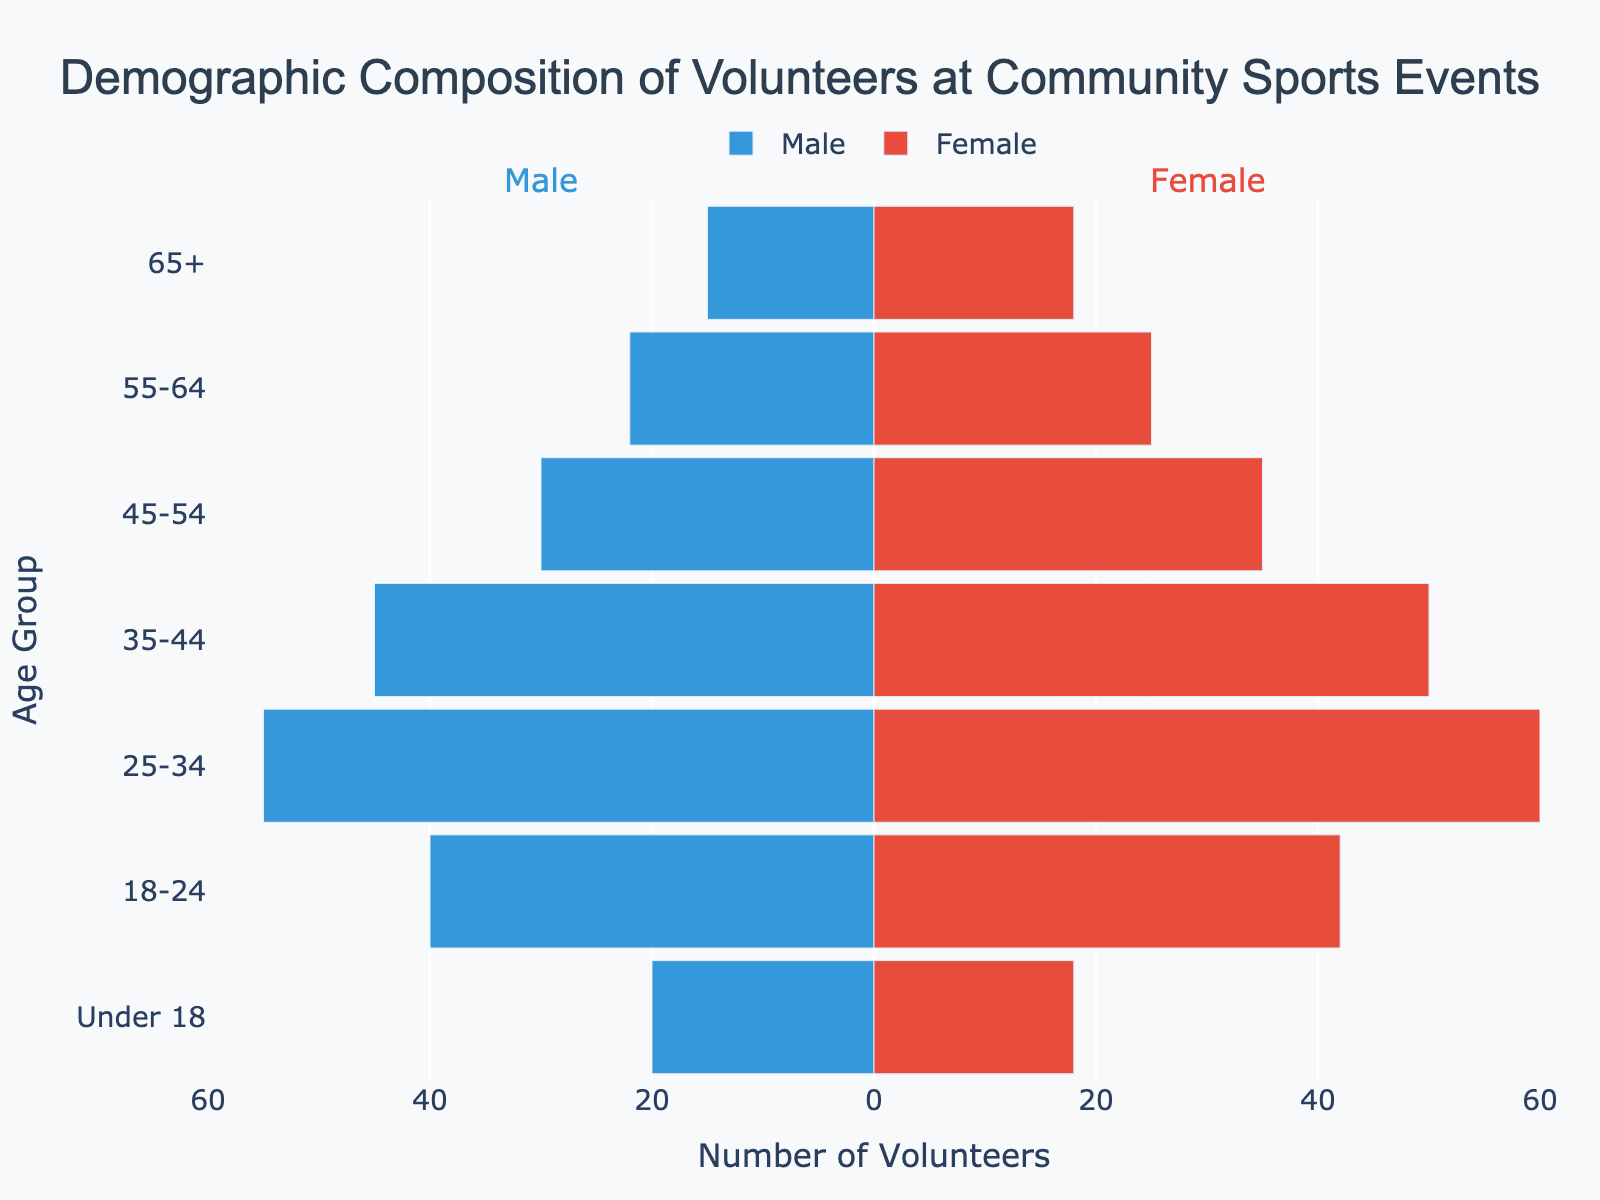Who has more volunteers in the 55-64 age group, males or females? By looking at the values for the 55-64 age group, females have 25 volunteers while males have 22 volunteers.
Answer: Females What is the title of the chart? The title is displayed at the top of the chart and reads "Demographic Composition of Volunteers at Community Sports Events".
Answer: Demographic Composition of Volunteers at Community Sports Events Which age group has the highest number of male volunteers? By referring to the male volunteer values for each age group, the 25-34 age group has the highest number with 55 male volunteers.
Answer: 25-34 What is the total number of volunteers in the 18-24 age group? Summing the values for males and females in the 18-24 age group: 40 (males) + 42 (females) = 82.
Answer: 82 How many more female volunteers are there in the 35-44 age group than male volunteers? The female volunteers in the 35-44 age group are 50, and male volunteers are 45. The difference is 50 - 45 = 5.
Answer: 5 Compare the total number of volunteers under 18 to the total number of volunteers aged 55-64. Which group has more volunteers? The total number of volunteers under 18 is 20 (male) + 18 (female) = 38, and aged 55-64 is 22 (male) + 25 (female) = 47. The 55-64 age group has more volunteers.
Answer: 55-64 Which age group has an equal or almost equal number of male and female volunteers? By comparing the values, the under 18 group has 20 male volunteers and 18 female volunteers, which is nearly equal.
Answer: Under 18 What is the difference in the number of female volunteers between the 45-54 and the 55-64 age groups? The number of female volunteers in the 45-54 age group is 35 and in the 55-64 age group is 25. The difference is 35 - 25 = 10.
Answer: 10 Which gender has more volunteers overall, considering all age groups? Summing the values for male volunteers across all age groups: 15 + 22 + 30 + 45 + 55 + 40 + 20 = 227. Summing the values for female volunteers: 18 + 25 + 35 + 50 + 60 + 42 + 18 = 248. Females have more volunteers overall.
Answer: Females 